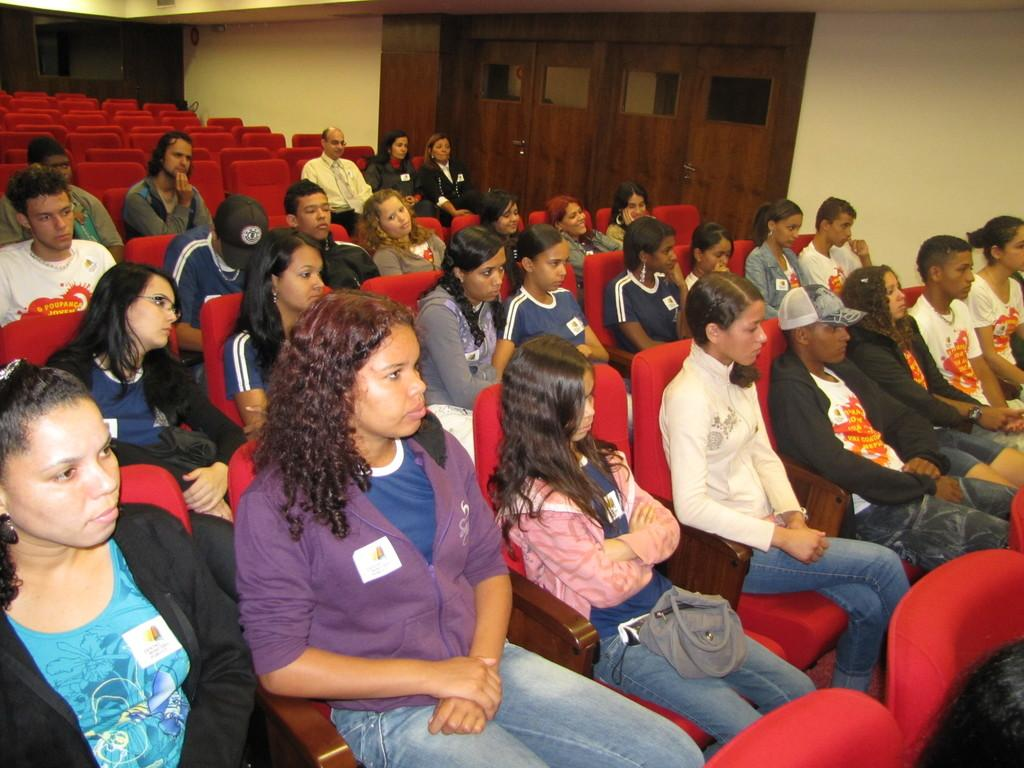What is happening in the image? There is a group of people in the image. What are the people doing in the image? The people are sitting on chairs. What can be seen in the background of the image? There is a wall and doors in the background of the image. What type of pipe can be seen in the image? There is no pipe present in the image. Are there any women in the image? The provided facts do not specify the gender of the people in the image, so we cannot definitively answer whether there are any women present. 